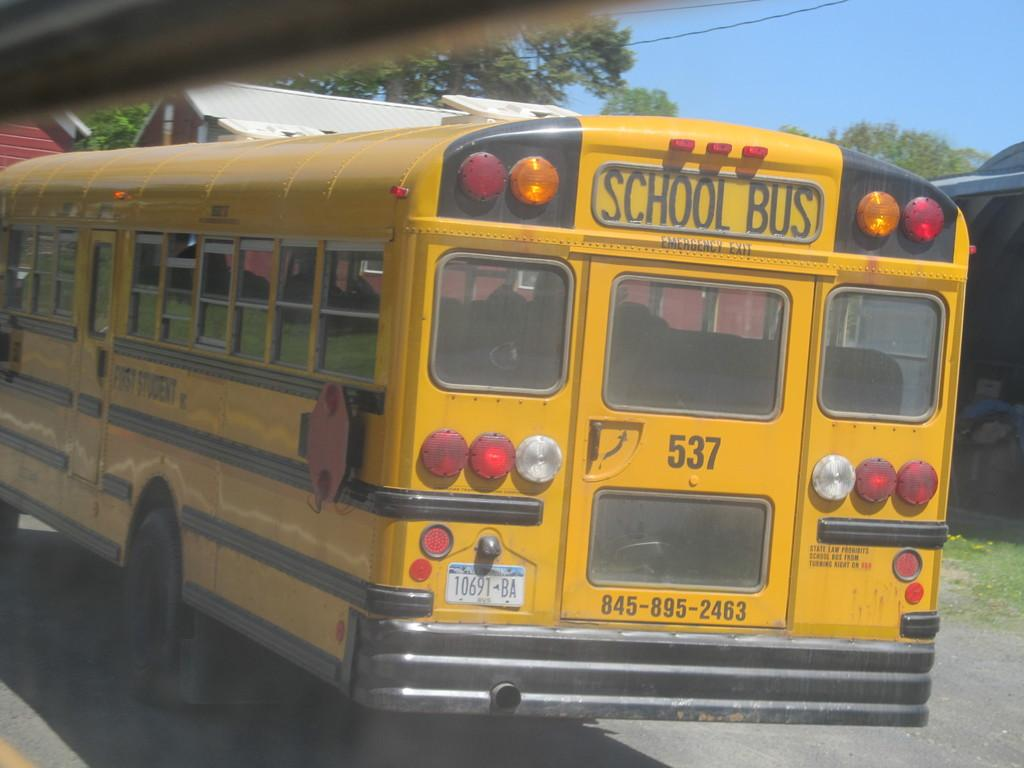What is the main subject of the picture? The main subject of the picture is a school bus. What is the school bus doing in the image? The school bus is moving on the road. What features can be seen on the school bus? The school bus has windows and a door. What can be seen in the background of the image? There is a building and trees in the image. What type of spoon is being used to power the school bus in the image? There is no spoon or any indication of powering the school bus in the image; it is simply moving on the road. What type of vest is the driver wearing in the image? There is no driver visible in the image, so it is impossible to determine what type of vest they might be wearing. 